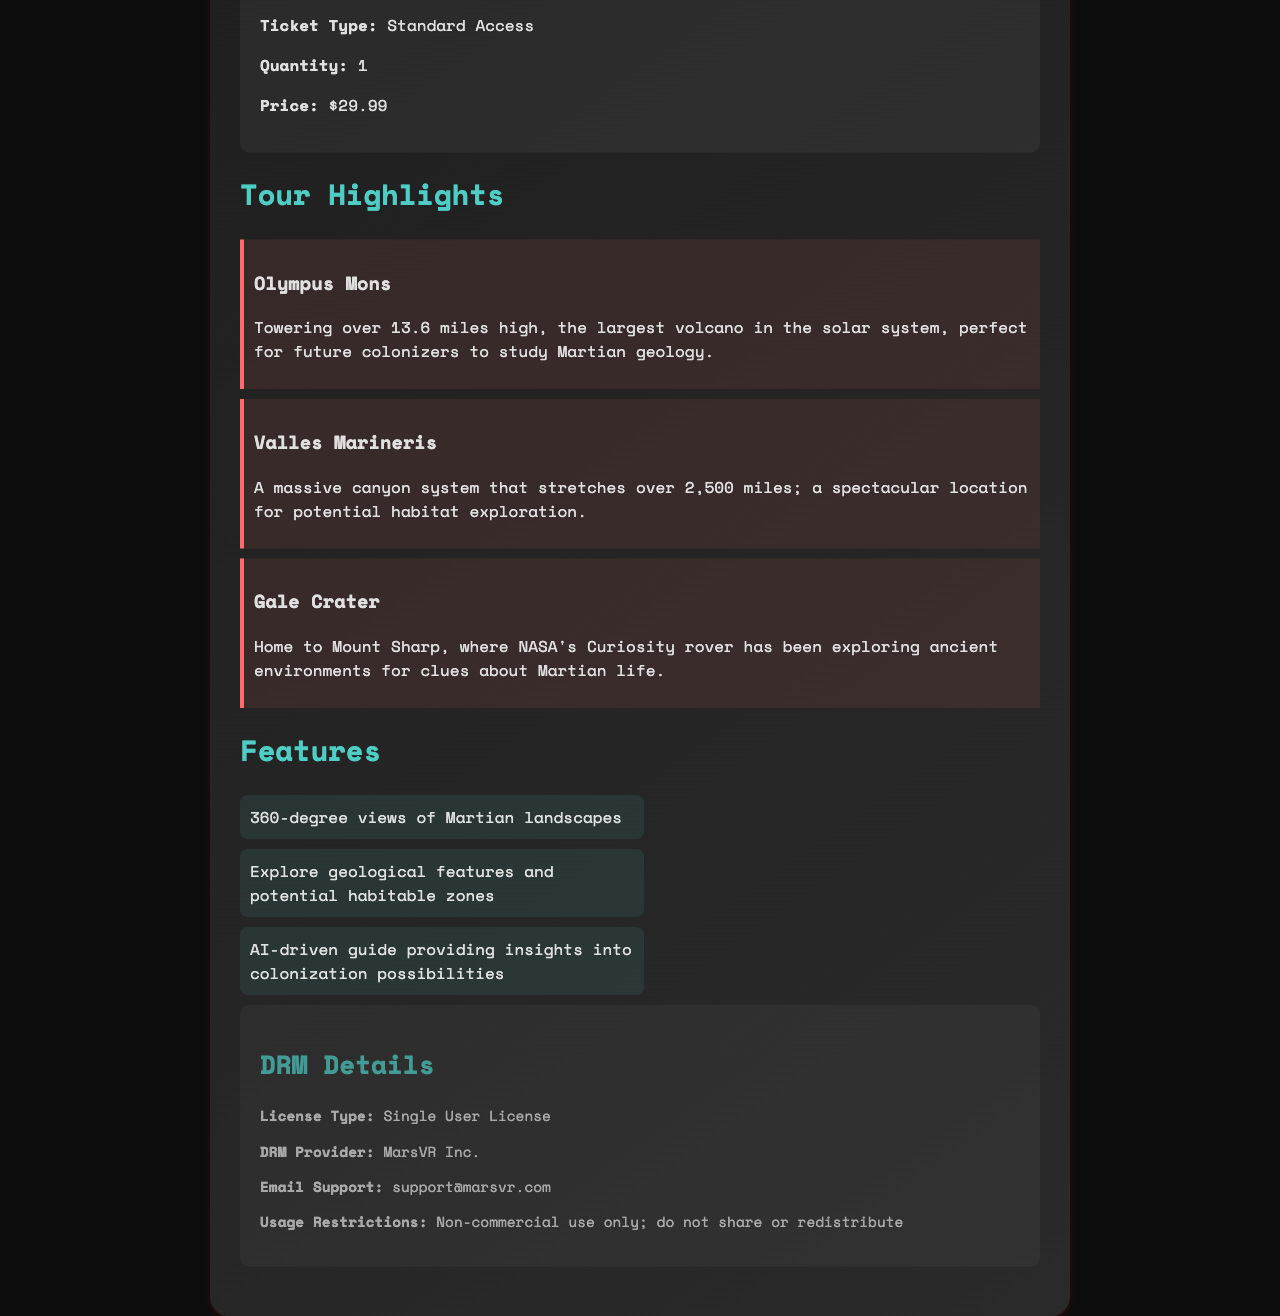What is the transaction ID? The transaction ID is a unique identifier for the purchase, found in the document.
Answer: MR20231020VR What is the ticket price? The ticket price is specified under customer information.
Answer: $29.99 What date is the tour scheduled? The date of the virtual reality tour is mentioned at the top of the document.
Answer: October 20, 2023 Who is the DRM provider? The document lists MarsVR Inc. as the provider of digital rights management.
Answer: MarsVR Inc What is the ticket type? The customer information section indicates the type of ticket purchased.
Answer: Standard Access How many highlights are listed? The number of highlights can be counted in the document section dedicated to tour highlights.
Answer: 3 What feature allows exploration of landscapes? The document mentions specific features that enhance the tour experience, and one pertains to landscape exploration.
Answer: 360-degree views of Martian landscapes What is the usage restriction for the VR content? The DRM details section specifies how the virtual reality content can be used.
Answer: Non-commercial use only; do not share or redistribute What time is the tour? The scheduled time for the virtual reality tour is mentioned in the document.
Answer: 2:00 PM UTC 